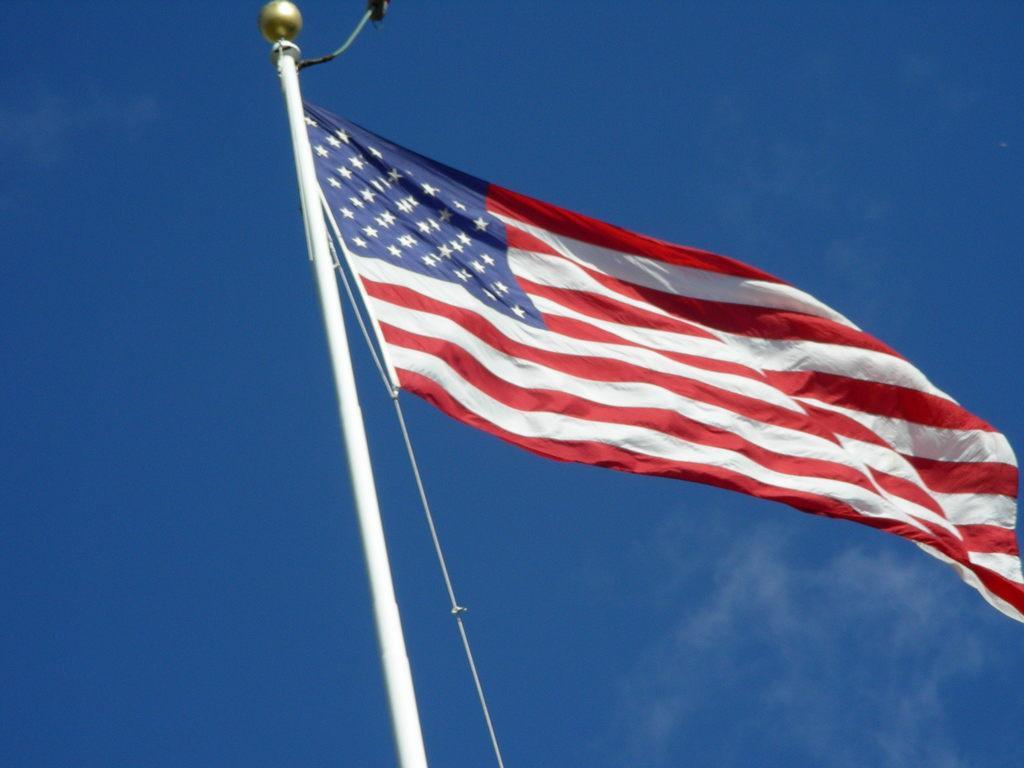Could you give a brief overview of what you see in this image? In this picture there is a flag on the pole and the flag is in red, white and in blue color. At the top there is sky. 